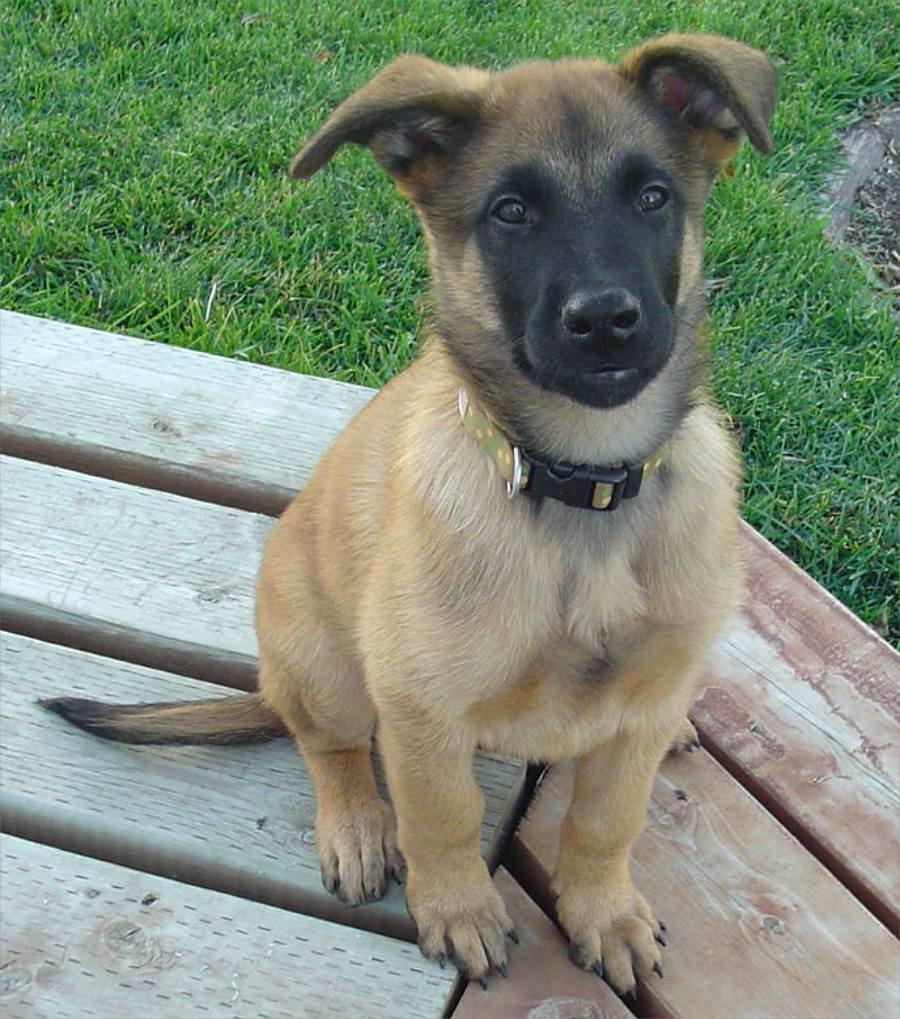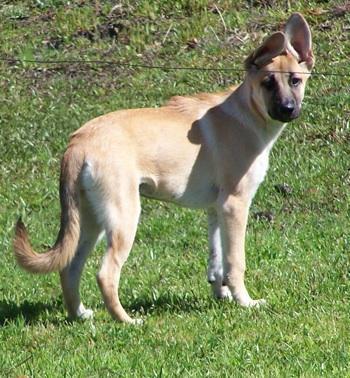The first image is the image on the left, the second image is the image on the right. For the images displayed, is the sentence "There are exactly two German Shepherd dogs and either they both have collars around their neck or neither do." factually correct? Answer yes or no. No. The first image is the image on the left, the second image is the image on the right. Considering the images on both sides, is "The dogs are looking in the same direction" valid? Answer yes or no. Yes. 